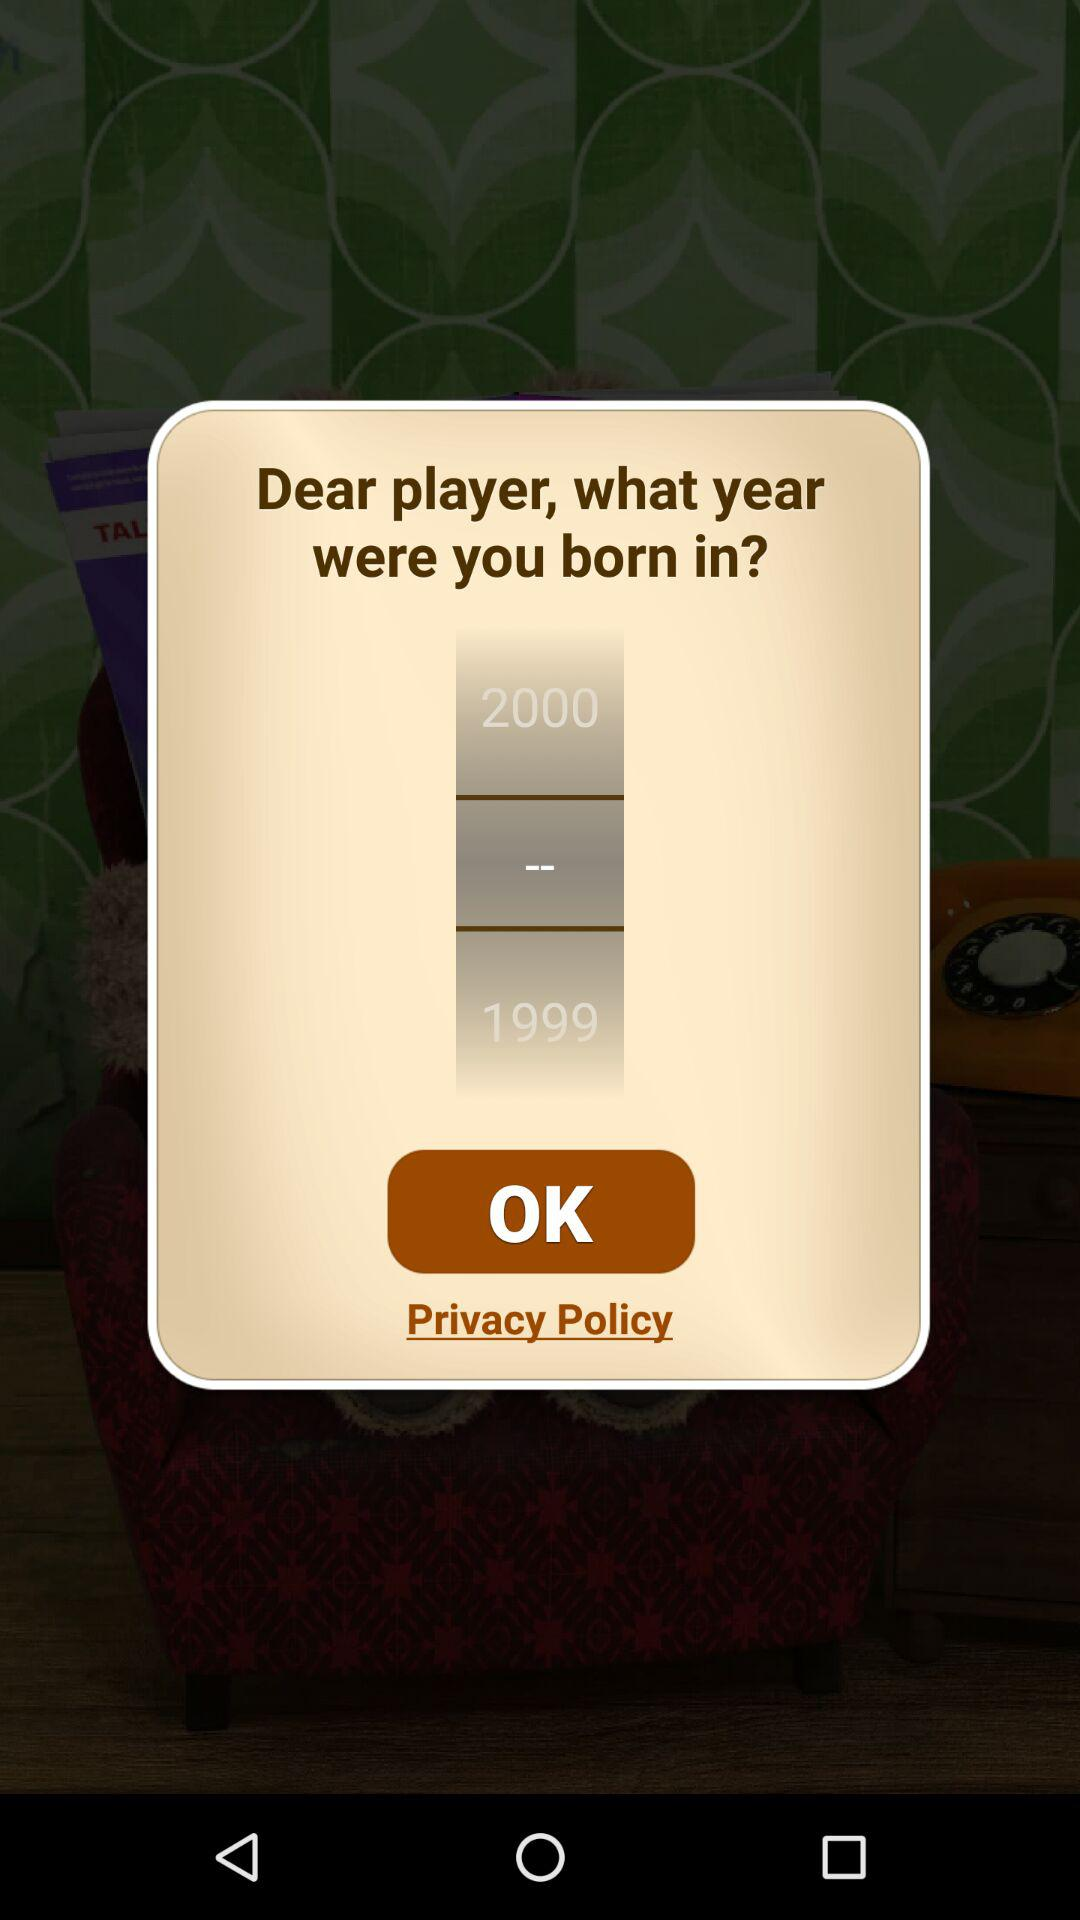How many years apart are the two birth years?
Answer the question using a single word or phrase. 1 